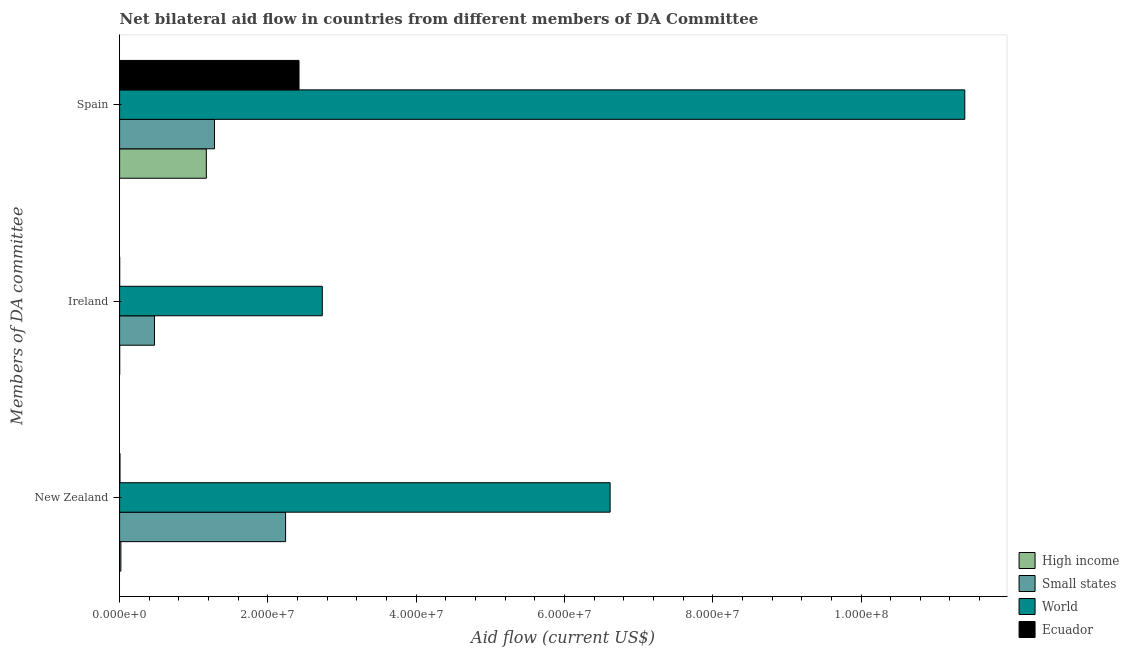How many different coloured bars are there?
Your answer should be very brief. 4. How many groups of bars are there?
Your answer should be very brief. 3. Are the number of bars per tick equal to the number of legend labels?
Your answer should be very brief. Yes. Are the number of bars on each tick of the Y-axis equal?
Make the answer very short. Yes. How many bars are there on the 3rd tick from the top?
Offer a very short reply. 4. How many bars are there on the 2nd tick from the bottom?
Offer a very short reply. 4. What is the label of the 2nd group of bars from the top?
Provide a succinct answer. Ireland. What is the amount of aid provided by spain in High income?
Offer a very short reply. 1.17e+07. Across all countries, what is the maximum amount of aid provided by spain?
Provide a succinct answer. 1.14e+08. Across all countries, what is the minimum amount of aid provided by ireland?
Provide a succinct answer. 10000. What is the total amount of aid provided by new zealand in the graph?
Your answer should be very brief. 8.88e+07. What is the difference between the amount of aid provided by ireland in Ecuador and that in World?
Keep it short and to the point. -2.73e+07. What is the difference between the amount of aid provided by spain in High income and the amount of aid provided by new zealand in World?
Your answer should be very brief. -5.45e+07. What is the average amount of aid provided by ireland per country?
Provide a succinct answer. 8.02e+06. What is the difference between the amount of aid provided by new zealand and amount of aid provided by ireland in Ecuador?
Offer a terse response. 4.00e+04. What is the ratio of the amount of aid provided by spain in Small states to that in Ecuador?
Keep it short and to the point. 0.53. What is the difference between the highest and the second highest amount of aid provided by new zealand?
Make the answer very short. 4.38e+07. What is the difference between the highest and the lowest amount of aid provided by ireland?
Offer a very short reply. 2.73e+07. In how many countries, is the amount of aid provided by new zealand greater than the average amount of aid provided by new zealand taken over all countries?
Provide a succinct answer. 2. What does the 2nd bar from the bottom in New Zealand represents?
Your answer should be compact. Small states. How many bars are there?
Give a very brief answer. 12. Are all the bars in the graph horizontal?
Make the answer very short. Yes. What is the difference between two consecutive major ticks on the X-axis?
Provide a short and direct response. 2.00e+07. Does the graph contain any zero values?
Keep it short and to the point. No. Does the graph contain grids?
Your answer should be very brief. No. How are the legend labels stacked?
Make the answer very short. Vertical. What is the title of the graph?
Provide a succinct answer. Net bilateral aid flow in countries from different members of DA Committee. What is the label or title of the X-axis?
Provide a succinct answer. Aid flow (current US$). What is the label or title of the Y-axis?
Ensure brevity in your answer.  Members of DA committee. What is the Aid flow (current US$) in High income in New Zealand?
Ensure brevity in your answer.  1.70e+05. What is the Aid flow (current US$) of Small states in New Zealand?
Provide a short and direct response. 2.24e+07. What is the Aid flow (current US$) in World in New Zealand?
Your answer should be very brief. 6.62e+07. What is the Aid flow (current US$) in Ecuador in New Zealand?
Keep it short and to the point. 5.00e+04. What is the Aid flow (current US$) in Small states in Ireland?
Ensure brevity in your answer.  4.71e+06. What is the Aid flow (current US$) of World in Ireland?
Ensure brevity in your answer.  2.73e+07. What is the Aid flow (current US$) in High income in Spain?
Ensure brevity in your answer.  1.17e+07. What is the Aid flow (current US$) in Small states in Spain?
Offer a very short reply. 1.28e+07. What is the Aid flow (current US$) in World in Spain?
Give a very brief answer. 1.14e+08. What is the Aid flow (current US$) in Ecuador in Spain?
Ensure brevity in your answer.  2.42e+07. Across all Members of DA committee, what is the maximum Aid flow (current US$) in High income?
Provide a succinct answer. 1.17e+07. Across all Members of DA committee, what is the maximum Aid flow (current US$) in Small states?
Ensure brevity in your answer.  2.24e+07. Across all Members of DA committee, what is the maximum Aid flow (current US$) of World?
Your answer should be very brief. 1.14e+08. Across all Members of DA committee, what is the maximum Aid flow (current US$) of Ecuador?
Provide a short and direct response. 2.42e+07. Across all Members of DA committee, what is the minimum Aid flow (current US$) in Small states?
Keep it short and to the point. 4.71e+06. Across all Members of DA committee, what is the minimum Aid flow (current US$) of World?
Offer a very short reply. 2.73e+07. What is the total Aid flow (current US$) of High income in the graph?
Your response must be concise. 1.19e+07. What is the total Aid flow (current US$) in Small states in the graph?
Offer a terse response. 3.99e+07. What is the total Aid flow (current US$) in World in the graph?
Your answer should be very brief. 2.08e+08. What is the total Aid flow (current US$) in Ecuador in the graph?
Provide a succinct answer. 2.43e+07. What is the difference between the Aid flow (current US$) of Small states in New Zealand and that in Ireland?
Provide a succinct answer. 1.77e+07. What is the difference between the Aid flow (current US$) of World in New Zealand and that in Ireland?
Keep it short and to the point. 3.88e+07. What is the difference between the Aid flow (current US$) in Ecuador in New Zealand and that in Ireland?
Keep it short and to the point. 4.00e+04. What is the difference between the Aid flow (current US$) in High income in New Zealand and that in Spain?
Your response must be concise. -1.15e+07. What is the difference between the Aid flow (current US$) in Small states in New Zealand and that in Spain?
Keep it short and to the point. 9.59e+06. What is the difference between the Aid flow (current US$) in World in New Zealand and that in Spain?
Give a very brief answer. -4.78e+07. What is the difference between the Aid flow (current US$) of Ecuador in New Zealand and that in Spain?
Make the answer very short. -2.42e+07. What is the difference between the Aid flow (current US$) in High income in Ireland and that in Spain?
Your answer should be very brief. -1.17e+07. What is the difference between the Aid flow (current US$) of Small states in Ireland and that in Spain?
Offer a very short reply. -8.09e+06. What is the difference between the Aid flow (current US$) in World in Ireland and that in Spain?
Offer a very short reply. -8.67e+07. What is the difference between the Aid flow (current US$) of Ecuador in Ireland and that in Spain?
Make the answer very short. -2.42e+07. What is the difference between the Aid flow (current US$) of High income in New Zealand and the Aid flow (current US$) of Small states in Ireland?
Your answer should be compact. -4.54e+06. What is the difference between the Aid flow (current US$) in High income in New Zealand and the Aid flow (current US$) in World in Ireland?
Make the answer very short. -2.72e+07. What is the difference between the Aid flow (current US$) in High income in New Zealand and the Aid flow (current US$) in Ecuador in Ireland?
Your answer should be compact. 1.60e+05. What is the difference between the Aid flow (current US$) of Small states in New Zealand and the Aid flow (current US$) of World in Ireland?
Provide a succinct answer. -4.95e+06. What is the difference between the Aid flow (current US$) in Small states in New Zealand and the Aid flow (current US$) in Ecuador in Ireland?
Keep it short and to the point. 2.24e+07. What is the difference between the Aid flow (current US$) of World in New Zealand and the Aid flow (current US$) of Ecuador in Ireland?
Provide a succinct answer. 6.62e+07. What is the difference between the Aid flow (current US$) in High income in New Zealand and the Aid flow (current US$) in Small states in Spain?
Offer a terse response. -1.26e+07. What is the difference between the Aid flow (current US$) of High income in New Zealand and the Aid flow (current US$) of World in Spain?
Your answer should be compact. -1.14e+08. What is the difference between the Aid flow (current US$) in High income in New Zealand and the Aid flow (current US$) in Ecuador in Spain?
Offer a very short reply. -2.40e+07. What is the difference between the Aid flow (current US$) in Small states in New Zealand and the Aid flow (current US$) in World in Spain?
Offer a terse response. -9.16e+07. What is the difference between the Aid flow (current US$) of Small states in New Zealand and the Aid flow (current US$) of Ecuador in Spain?
Offer a very short reply. -1.81e+06. What is the difference between the Aid flow (current US$) of World in New Zealand and the Aid flow (current US$) of Ecuador in Spain?
Offer a very short reply. 4.20e+07. What is the difference between the Aid flow (current US$) in High income in Ireland and the Aid flow (current US$) in Small states in Spain?
Offer a very short reply. -1.28e+07. What is the difference between the Aid flow (current US$) of High income in Ireland and the Aid flow (current US$) of World in Spain?
Offer a terse response. -1.14e+08. What is the difference between the Aid flow (current US$) in High income in Ireland and the Aid flow (current US$) in Ecuador in Spain?
Give a very brief answer. -2.42e+07. What is the difference between the Aid flow (current US$) in Small states in Ireland and the Aid flow (current US$) in World in Spain?
Ensure brevity in your answer.  -1.09e+08. What is the difference between the Aid flow (current US$) of Small states in Ireland and the Aid flow (current US$) of Ecuador in Spain?
Make the answer very short. -1.95e+07. What is the difference between the Aid flow (current US$) in World in Ireland and the Aid flow (current US$) in Ecuador in Spain?
Provide a short and direct response. 3.14e+06. What is the average Aid flow (current US$) of High income per Members of DA committee?
Offer a terse response. 3.96e+06. What is the average Aid flow (current US$) of Small states per Members of DA committee?
Make the answer very short. 1.33e+07. What is the average Aid flow (current US$) in World per Members of DA committee?
Your answer should be very brief. 6.92e+07. What is the average Aid flow (current US$) of Ecuador per Members of DA committee?
Give a very brief answer. 8.09e+06. What is the difference between the Aid flow (current US$) in High income and Aid flow (current US$) in Small states in New Zealand?
Keep it short and to the point. -2.22e+07. What is the difference between the Aid flow (current US$) in High income and Aid flow (current US$) in World in New Zealand?
Give a very brief answer. -6.60e+07. What is the difference between the Aid flow (current US$) in Small states and Aid flow (current US$) in World in New Zealand?
Your answer should be very brief. -4.38e+07. What is the difference between the Aid flow (current US$) of Small states and Aid flow (current US$) of Ecuador in New Zealand?
Your response must be concise. 2.23e+07. What is the difference between the Aid flow (current US$) in World and Aid flow (current US$) in Ecuador in New Zealand?
Give a very brief answer. 6.61e+07. What is the difference between the Aid flow (current US$) in High income and Aid flow (current US$) in Small states in Ireland?
Your answer should be compact. -4.70e+06. What is the difference between the Aid flow (current US$) in High income and Aid flow (current US$) in World in Ireland?
Your response must be concise. -2.73e+07. What is the difference between the Aid flow (current US$) in High income and Aid flow (current US$) in Ecuador in Ireland?
Your answer should be very brief. 0. What is the difference between the Aid flow (current US$) of Small states and Aid flow (current US$) of World in Ireland?
Offer a terse response. -2.26e+07. What is the difference between the Aid flow (current US$) in Small states and Aid flow (current US$) in Ecuador in Ireland?
Your answer should be very brief. 4.70e+06. What is the difference between the Aid flow (current US$) of World and Aid flow (current US$) of Ecuador in Ireland?
Your answer should be very brief. 2.73e+07. What is the difference between the Aid flow (current US$) in High income and Aid flow (current US$) in Small states in Spain?
Offer a very short reply. -1.10e+06. What is the difference between the Aid flow (current US$) of High income and Aid flow (current US$) of World in Spain?
Provide a short and direct response. -1.02e+08. What is the difference between the Aid flow (current US$) in High income and Aid flow (current US$) in Ecuador in Spain?
Make the answer very short. -1.25e+07. What is the difference between the Aid flow (current US$) in Small states and Aid flow (current US$) in World in Spain?
Offer a terse response. -1.01e+08. What is the difference between the Aid flow (current US$) in Small states and Aid flow (current US$) in Ecuador in Spain?
Your answer should be very brief. -1.14e+07. What is the difference between the Aid flow (current US$) of World and Aid flow (current US$) of Ecuador in Spain?
Keep it short and to the point. 8.98e+07. What is the ratio of the Aid flow (current US$) of High income in New Zealand to that in Ireland?
Give a very brief answer. 17. What is the ratio of the Aid flow (current US$) of Small states in New Zealand to that in Ireland?
Offer a very short reply. 4.75. What is the ratio of the Aid flow (current US$) in World in New Zealand to that in Ireland?
Provide a succinct answer. 2.42. What is the ratio of the Aid flow (current US$) in High income in New Zealand to that in Spain?
Your answer should be very brief. 0.01. What is the ratio of the Aid flow (current US$) in Small states in New Zealand to that in Spain?
Ensure brevity in your answer.  1.75. What is the ratio of the Aid flow (current US$) in World in New Zealand to that in Spain?
Your response must be concise. 0.58. What is the ratio of the Aid flow (current US$) in Ecuador in New Zealand to that in Spain?
Make the answer very short. 0. What is the ratio of the Aid flow (current US$) of High income in Ireland to that in Spain?
Offer a very short reply. 0. What is the ratio of the Aid flow (current US$) in Small states in Ireland to that in Spain?
Ensure brevity in your answer.  0.37. What is the ratio of the Aid flow (current US$) of World in Ireland to that in Spain?
Offer a terse response. 0.24. What is the difference between the highest and the second highest Aid flow (current US$) in High income?
Offer a terse response. 1.15e+07. What is the difference between the highest and the second highest Aid flow (current US$) of Small states?
Ensure brevity in your answer.  9.59e+06. What is the difference between the highest and the second highest Aid flow (current US$) in World?
Give a very brief answer. 4.78e+07. What is the difference between the highest and the second highest Aid flow (current US$) in Ecuador?
Your response must be concise. 2.42e+07. What is the difference between the highest and the lowest Aid flow (current US$) of High income?
Your answer should be compact. 1.17e+07. What is the difference between the highest and the lowest Aid flow (current US$) in Small states?
Your response must be concise. 1.77e+07. What is the difference between the highest and the lowest Aid flow (current US$) of World?
Keep it short and to the point. 8.67e+07. What is the difference between the highest and the lowest Aid flow (current US$) of Ecuador?
Offer a very short reply. 2.42e+07. 